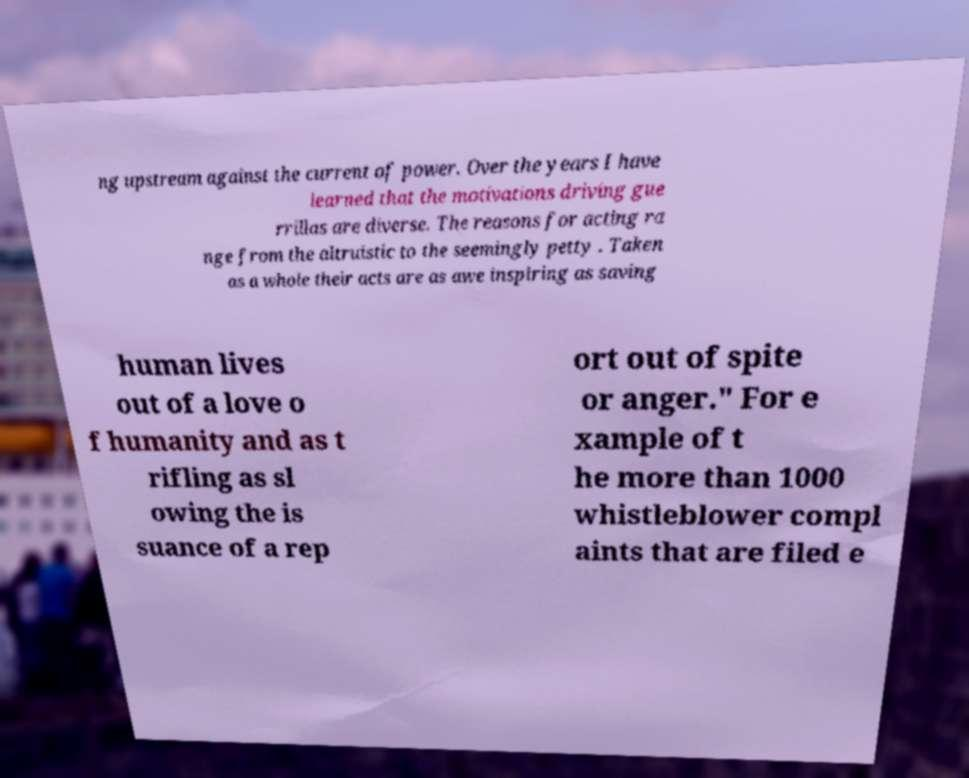Could you assist in decoding the text presented in this image and type it out clearly? ng upstream against the current of power. Over the years I have learned that the motivations driving gue rrillas are diverse. The reasons for acting ra nge from the altruistic to the seemingly petty . Taken as a whole their acts are as awe inspiring as saving human lives out of a love o f humanity and as t rifling as sl owing the is suance of a rep ort out of spite or anger." For e xample of t he more than 1000 whistleblower compl aints that are filed e 